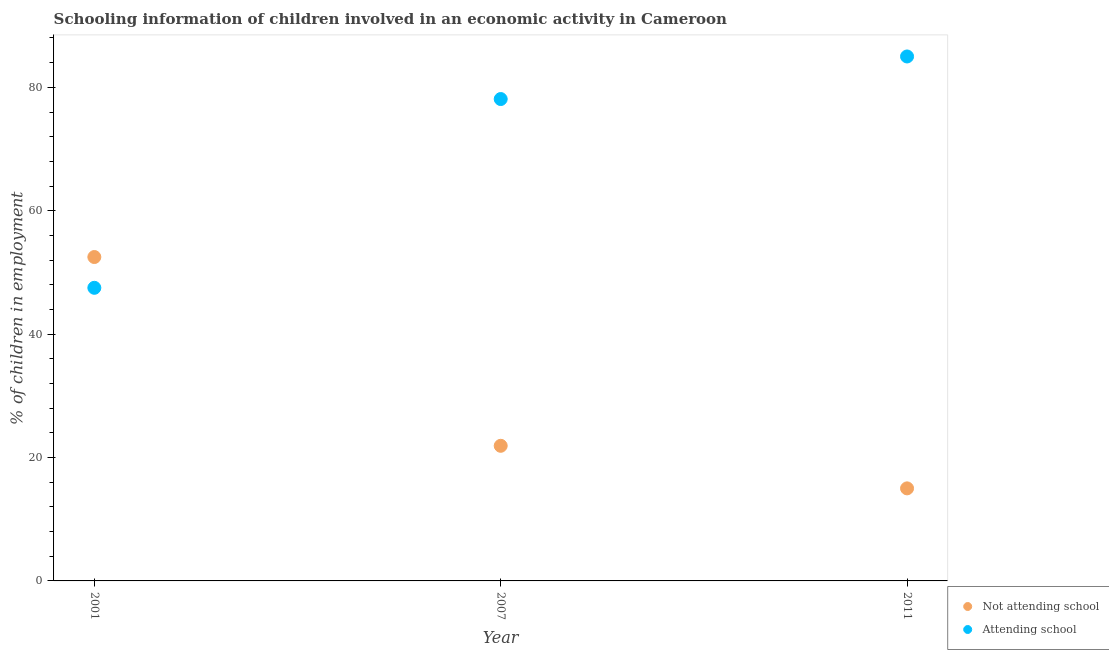How many different coloured dotlines are there?
Give a very brief answer. 2. What is the percentage of employed children who are attending school in 2007?
Ensure brevity in your answer.  78.1. Across all years, what is the maximum percentage of employed children who are attending school?
Your response must be concise. 85. Across all years, what is the minimum percentage of employed children who are attending school?
Provide a short and direct response. 47.51. In which year was the percentage of employed children who are not attending school minimum?
Offer a very short reply. 2011. What is the total percentage of employed children who are attending school in the graph?
Keep it short and to the point. 210.61. What is the difference between the percentage of employed children who are attending school in 2001 and that in 2007?
Offer a very short reply. -30.59. What is the difference between the percentage of employed children who are not attending school in 2011 and the percentage of employed children who are attending school in 2001?
Your answer should be compact. -32.51. What is the average percentage of employed children who are attending school per year?
Make the answer very short. 70.2. In the year 2001, what is the difference between the percentage of employed children who are not attending school and percentage of employed children who are attending school?
Your answer should be compact. 4.99. What is the ratio of the percentage of employed children who are attending school in 2001 to that in 2011?
Offer a terse response. 0.56. Is the difference between the percentage of employed children who are attending school in 2001 and 2011 greater than the difference between the percentage of employed children who are not attending school in 2001 and 2011?
Ensure brevity in your answer.  No. What is the difference between the highest and the second highest percentage of employed children who are not attending school?
Your answer should be compact. 30.59. What is the difference between the highest and the lowest percentage of employed children who are attending school?
Provide a succinct answer. 37.49. Does the percentage of employed children who are not attending school monotonically increase over the years?
Your answer should be compact. No. How many dotlines are there?
Offer a terse response. 2. What is the difference between two consecutive major ticks on the Y-axis?
Your answer should be compact. 20. Are the values on the major ticks of Y-axis written in scientific E-notation?
Offer a terse response. No. Does the graph contain any zero values?
Make the answer very short. No. Does the graph contain grids?
Your answer should be compact. No. Where does the legend appear in the graph?
Keep it short and to the point. Bottom right. What is the title of the graph?
Keep it short and to the point. Schooling information of children involved in an economic activity in Cameroon. Does "Largest city" appear as one of the legend labels in the graph?
Offer a terse response. No. What is the label or title of the X-axis?
Provide a succinct answer. Year. What is the label or title of the Y-axis?
Give a very brief answer. % of children in employment. What is the % of children in employment in Not attending school in 2001?
Ensure brevity in your answer.  52.49. What is the % of children in employment of Attending school in 2001?
Your response must be concise. 47.51. What is the % of children in employment in Not attending school in 2007?
Your response must be concise. 21.9. What is the % of children in employment of Attending school in 2007?
Your answer should be compact. 78.1. What is the % of children in employment in Attending school in 2011?
Give a very brief answer. 85. Across all years, what is the maximum % of children in employment in Not attending school?
Offer a very short reply. 52.49. Across all years, what is the maximum % of children in employment in Attending school?
Offer a terse response. 85. Across all years, what is the minimum % of children in employment of Attending school?
Give a very brief answer. 47.51. What is the total % of children in employment of Not attending school in the graph?
Your response must be concise. 89.39. What is the total % of children in employment of Attending school in the graph?
Your answer should be very brief. 210.61. What is the difference between the % of children in employment in Not attending school in 2001 and that in 2007?
Ensure brevity in your answer.  30.59. What is the difference between the % of children in employment of Attending school in 2001 and that in 2007?
Make the answer very short. -30.59. What is the difference between the % of children in employment of Not attending school in 2001 and that in 2011?
Offer a very short reply. 37.49. What is the difference between the % of children in employment of Attending school in 2001 and that in 2011?
Your answer should be very brief. -37.49. What is the difference between the % of children in employment in Not attending school in 2007 and that in 2011?
Provide a succinct answer. 6.9. What is the difference between the % of children in employment in Attending school in 2007 and that in 2011?
Provide a succinct answer. -6.9. What is the difference between the % of children in employment in Not attending school in 2001 and the % of children in employment in Attending school in 2007?
Your answer should be very brief. -25.61. What is the difference between the % of children in employment in Not attending school in 2001 and the % of children in employment in Attending school in 2011?
Keep it short and to the point. -32.51. What is the difference between the % of children in employment of Not attending school in 2007 and the % of children in employment of Attending school in 2011?
Provide a short and direct response. -63.1. What is the average % of children in employment in Not attending school per year?
Provide a short and direct response. 29.8. What is the average % of children in employment of Attending school per year?
Your response must be concise. 70.2. In the year 2001, what is the difference between the % of children in employment in Not attending school and % of children in employment in Attending school?
Ensure brevity in your answer.  4.99. In the year 2007, what is the difference between the % of children in employment in Not attending school and % of children in employment in Attending school?
Keep it short and to the point. -56.2. In the year 2011, what is the difference between the % of children in employment in Not attending school and % of children in employment in Attending school?
Keep it short and to the point. -70. What is the ratio of the % of children in employment of Not attending school in 2001 to that in 2007?
Your answer should be very brief. 2.4. What is the ratio of the % of children in employment in Attending school in 2001 to that in 2007?
Give a very brief answer. 0.61. What is the ratio of the % of children in employment of Not attending school in 2001 to that in 2011?
Offer a terse response. 3.5. What is the ratio of the % of children in employment in Attending school in 2001 to that in 2011?
Provide a succinct answer. 0.56. What is the ratio of the % of children in employment in Not attending school in 2007 to that in 2011?
Ensure brevity in your answer.  1.46. What is the ratio of the % of children in employment of Attending school in 2007 to that in 2011?
Provide a short and direct response. 0.92. What is the difference between the highest and the second highest % of children in employment of Not attending school?
Your answer should be compact. 30.59. What is the difference between the highest and the lowest % of children in employment in Not attending school?
Ensure brevity in your answer.  37.49. What is the difference between the highest and the lowest % of children in employment of Attending school?
Your response must be concise. 37.49. 